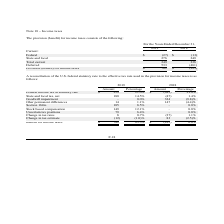From Lifeway Foods's financial document, What is the provision (benefit) for total current income taxes for 2018 and 2019 respectively? The document shows two values: 236 and 249. From the document: "Total current 249 236 Total current 249 236..." Also, What is the deferred provision (benefit) for income tax for 2018 and 2019 respectively? The document shows two values: (461) and 533. From the document: "Deferred 533 (461 )..." Also, What is the total provision (benefit) for income taxes in 2019? According to the financial document, 782. The relevant text states: "Provision (benefit) for income taxes $ 782 $ (225 )..." Also, can you calculate: What is the change in provision (benefit) for state and local income taxes between 2018 and 2019? Based on the calculation: 276-249, the result is 27. This is based on the information: "State and local 276 249 State and local 276 249..." The key data points involved are: 249, 276. Also, can you calculate: What is the average total current provision (benefit) for income taxes for 2018 and 2019? To answer this question, I need to perform calculations using the financial data. The calculation is: (236+249)/2, which equals 242.5. This is based on the information: "Total current 249 236 Total current 249 236..." The key data points involved are: 236, 249. Also, can you calculate: What is the percentage change in provisions (benefit) for state and local income taxes between 2018 and 2019? To answer this question, I need to perform calculations using the financial data. The calculation is: (276-249)/249, which equals 10.84 (percentage). This is based on the information: "State and local 276 249 State and local 276 249..." The key data points involved are: 249, 276. 